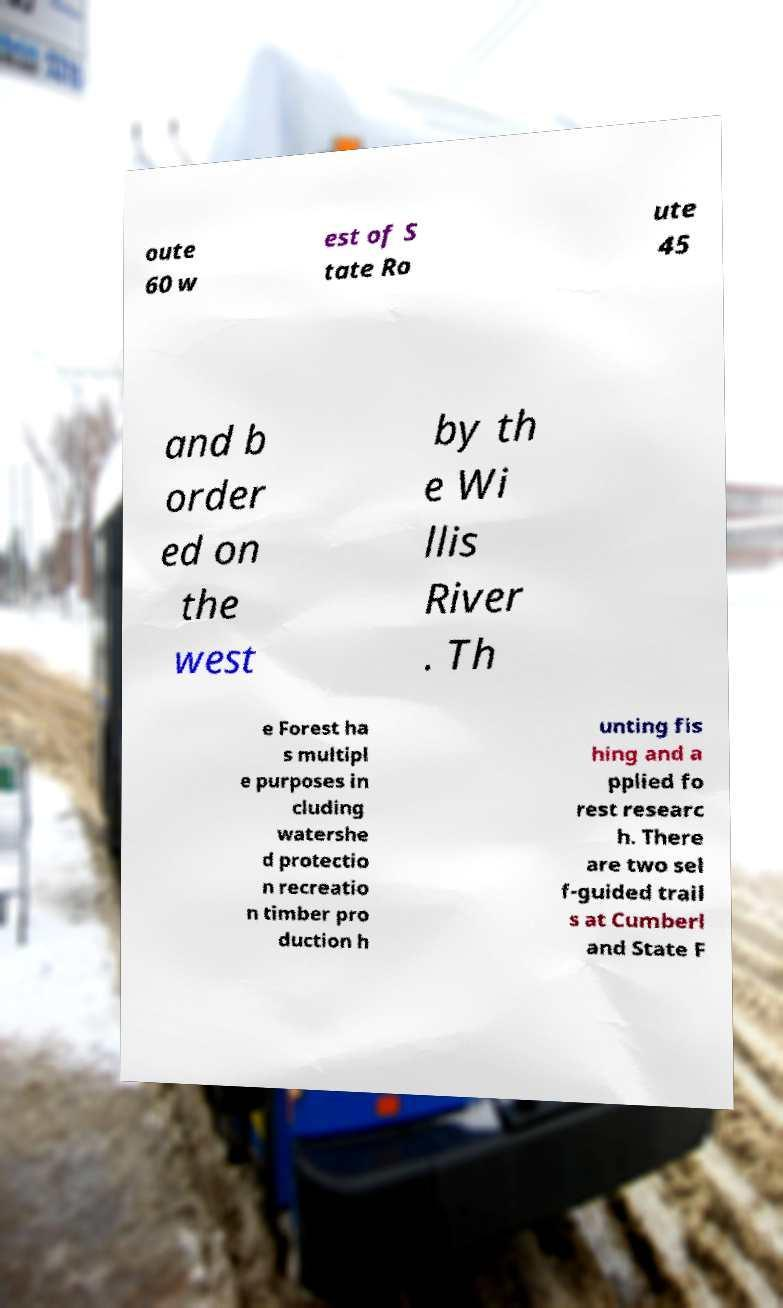What messages or text are displayed in this image? I need them in a readable, typed format. oute 60 w est of S tate Ro ute 45 and b order ed on the west by th e Wi llis River . Th e Forest ha s multipl e purposes in cluding watershe d protectio n recreatio n timber pro duction h unting fis hing and a pplied fo rest researc h. There are two sel f-guided trail s at Cumberl and State F 